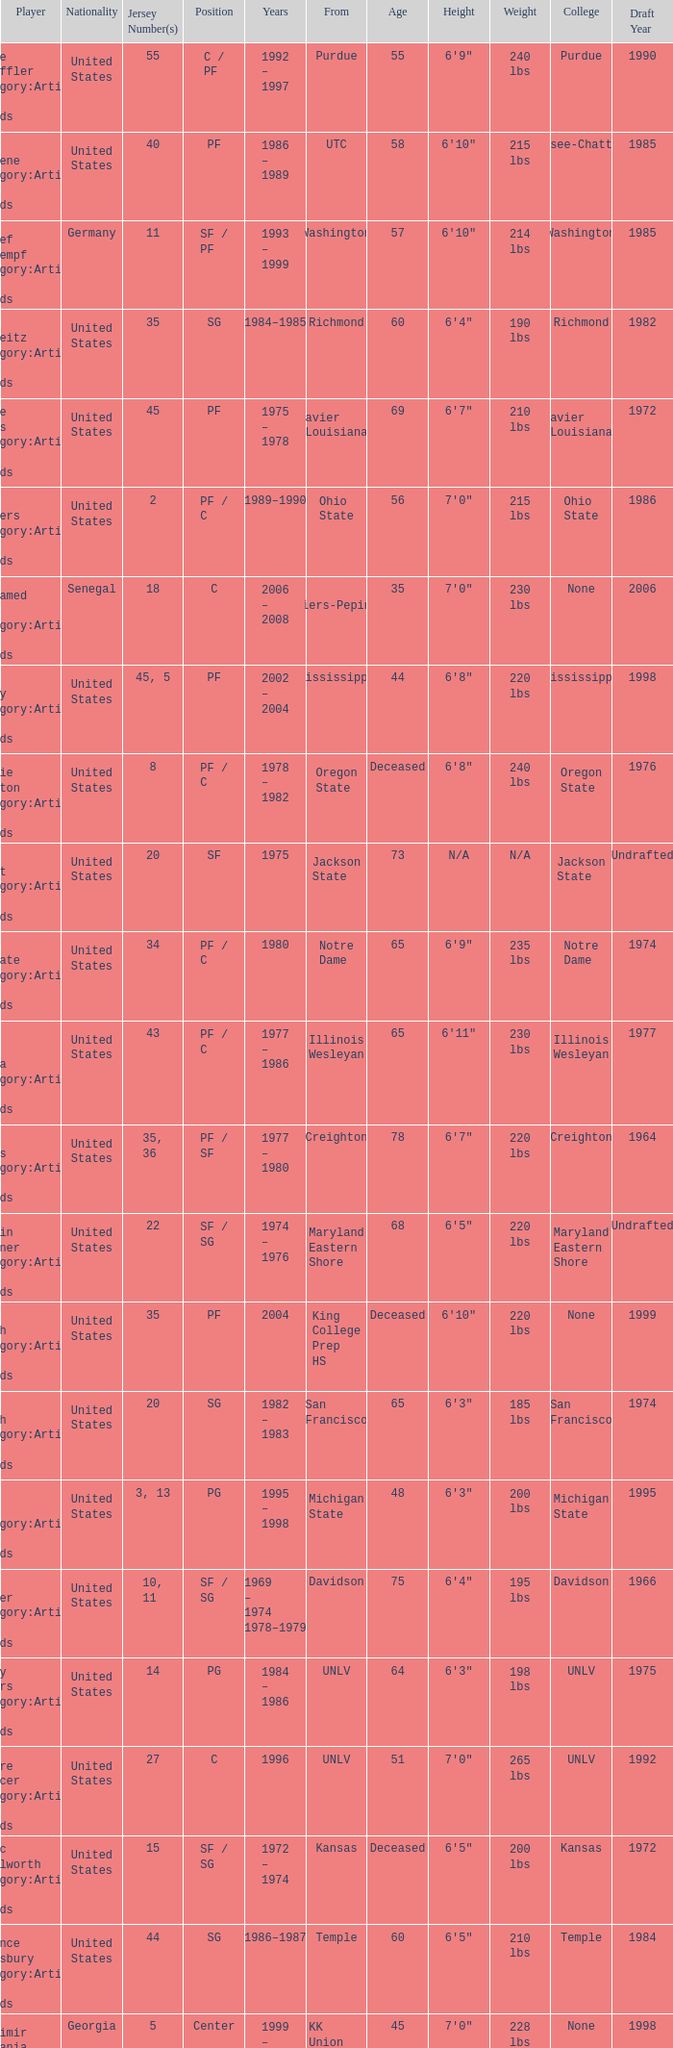Who wears the jersey number 20 and has the position of SG? Phil Smith Category:Articles with hCards, Jon Sundvold Category:Articles with hCards. 